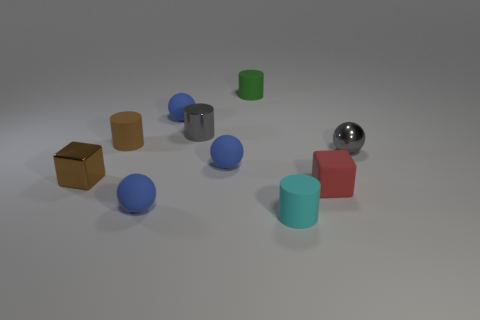How many things are either blue matte objects that are in front of the small brown metal thing or blue balls that are in front of the red block?
Give a very brief answer. 1. There is a rubber thing that is both in front of the small red rubber cube and on the left side of the small green rubber object; what is its size?
Your answer should be very brief. Small. There is a brown rubber object; is it the same shape as the gray metallic thing that is behind the gray shiny ball?
Ensure brevity in your answer.  Yes. How many things are tiny brown rubber objects on the left side of the small gray cylinder or large purple metal cylinders?
Keep it short and to the point. 1. Is the cyan thing made of the same material as the cube that is to the left of the green thing?
Make the answer very short. No. There is a small gray object that is on the right side of the small gray object that is to the left of the cyan matte cylinder; what shape is it?
Ensure brevity in your answer.  Sphere. There is a metallic cylinder; does it have the same color as the rubber ball behind the gray shiny sphere?
Provide a succinct answer. No. Is there anything else that is made of the same material as the tiny gray ball?
Your answer should be very brief. Yes. What is the shape of the tiny cyan thing?
Offer a terse response. Cylinder. There is a cyan object that is in front of the metallic thing that is behind the small brown rubber cylinder; what size is it?
Provide a short and direct response. Small. 